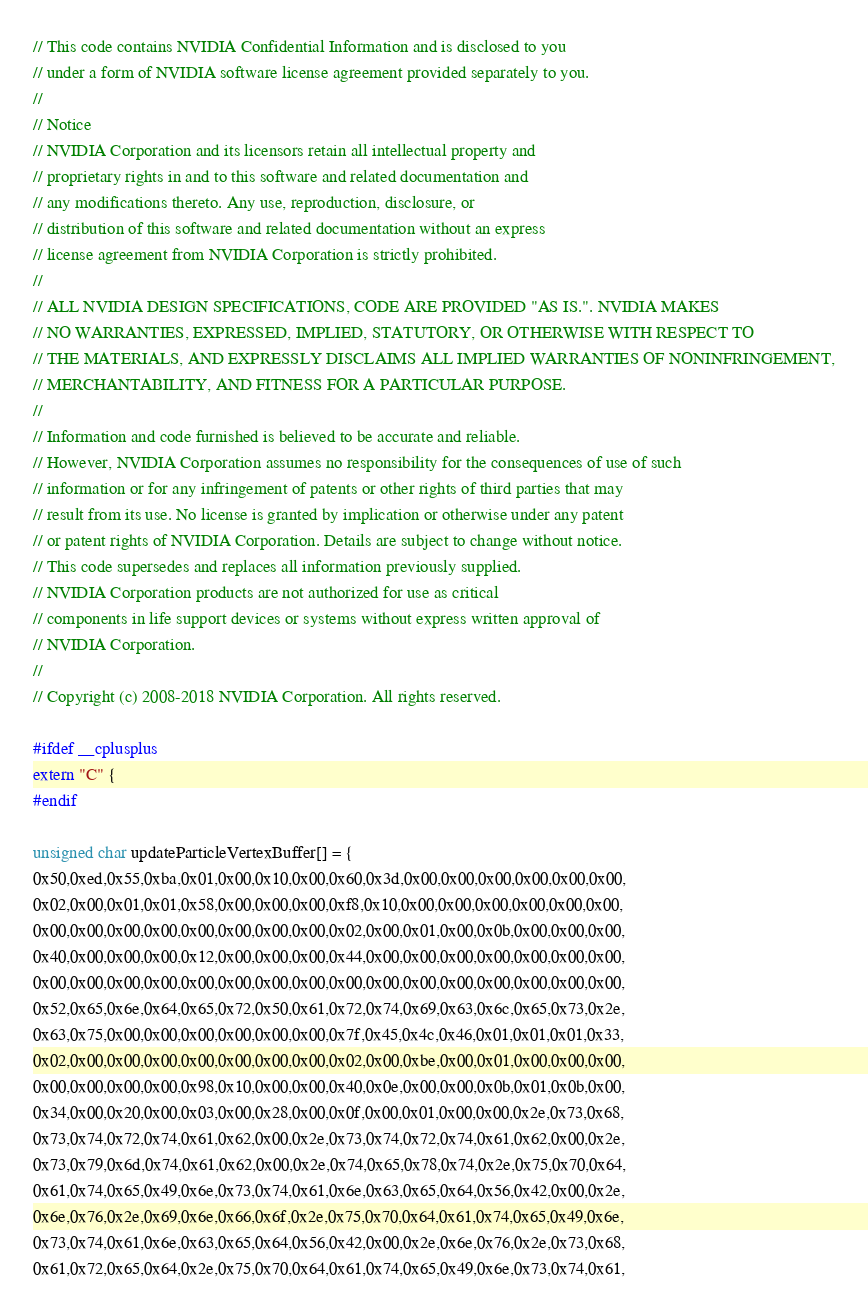<code> <loc_0><loc_0><loc_500><loc_500><_Cuda_>// This code contains NVIDIA Confidential Information and is disclosed to you
// under a form of NVIDIA software license agreement provided separately to you.
//
// Notice
// NVIDIA Corporation and its licensors retain all intellectual property and
// proprietary rights in and to this software and related documentation and
// any modifications thereto. Any use, reproduction, disclosure, or
// distribution of this software and related documentation without an express
// license agreement from NVIDIA Corporation is strictly prohibited.
//
// ALL NVIDIA DESIGN SPECIFICATIONS, CODE ARE PROVIDED "AS IS.". NVIDIA MAKES
// NO WARRANTIES, EXPRESSED, IMPLIED, STATUTORY, OR OTHERWISE WITH RESPECT TO
// THE MATERIALS, AND EXPRESSLY DISCLAIMS ALL IMPLIED WARRANTIES OF NONINFRINGEMENT,
// MERCHANTABILITY, AND FITNESS FOR A PARTICULAR PURPOSE.
//
// Information and code furnished is believed to be accurate and reliable.
// However, NVIDIA Corporation assumes no responsibility for the consequences of use of such
// information or for any infringement of patents or other rights of third parties that may
// result from its use. No license is granted by implication or otherwise under any patent
// or patent rights of NVIDIA Corporation. Details are subject to change without notice.
// This code supersedes and replaces all information previously supplied.
// NVIDIA Corporation products are not authorized for use as critical
// components in life support devices or systems without express written approval of
// NVIDIA Corporation.
//
// Copyright (c) 2008-2018 NVIDIA Corporation. All rights reserved.

#ifdef __cplusplus
extern "C" {
#endif

unsigned char updateParticleVertexBuffer[] = {
0x50,0xed,0x55,0xba,0x01,0x00,0x10,0x00,0x60,0x3d,0x00,0x00,0x00,0x00,0x00,0x00,
0x02,0x00,0x01,0x01,0x58,0x00,0x00,0x00,0xf8,0x10,0x00,0x00,0x00,0x00,0x00,0x00,
0x00,0x00,0x00,0x00,0x00,0x00,0x00,0x00,0x02,0x00,0x01,0x00,0x0b,0x00,0x00,0x00,
0x40,0x00,0x00,0x00,0x12,0x00,0x00,0x00,0x44,0x00,0x00,0x00,0x00,0x00,0x00,0x00,
0x00,0x00,0x00,0x00,0x00,0x00,0x00,0x00,0x00,0x00,0x00,0x00,0x00,0x00,0x00,0x00,
0x52,0x65,0x6e,0x64,0x65,0x72,0x50,0x61,0x72,0x74,0x69,0x63,0x6c,0x65,0x73,0x2e,
0x63,0x75,0x00,0x00,0x00,0x00,0x00,0x00,0x7f,0x45,0x4c,0x46,0x01,0x01,0x01,0x33,
0x02,0x00,0x00,0x00,0x00,0x00,0x00,0x00,0x02,0x00,0xbe,0x00,0x01,0x00,0x00,0x00,
0x00,0x00,0x00,0x00,0x98,0x10,0x00,0x00,0x40,0x0e,0x00,0x00,0x0b,0x01,0x0b,0x00,
0x34,0x00,0x20,0x00,0x03,0x00,0x28,0x00,0x0f,0x00,0x01,0x00,0x00,0x2e,0x73,0x68,
0x73,0x74,0x72,0x74,0x61,0x62,0x00,0x2e,0x73,0x74,0x72,0x74,0x61,0x62,0x00,0x2e,
0x73,0x79,0x6d,0x74,0x61,0x62,0x00,0x2e,0x74,0x65,0x78,0x74,0x2e,0x75,0x70,0x64,
0x61,0x74,0x65,0x49,0x6e,0x73,0x74,0x61,0x6e,0x63,0x65,0x64,0x56,0x42,0x00,0x2e,
0x6e,0x76,0x2e,0x69,0x6e,0x66,0x6f,0x2e,0x75,0x70,0x64,0x61,0x74,0x65,0x49,0x6e,
0x73,0x74,0x61,0x6e,0x63,0x65,0x64,0x56,0x42,0x00,0x2e,0x6e,0x76,0x2e,0x73,0x68,
0x61,0x72,0x65,0x64,0x2e,0x75,0x70,0x64,0x61,0x74,0x65,0x49,0x6e,0x73,0x74,0x61,</code> 